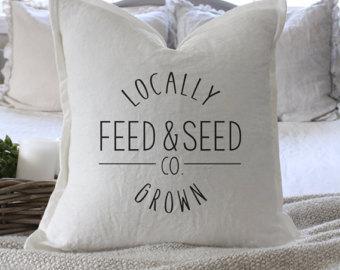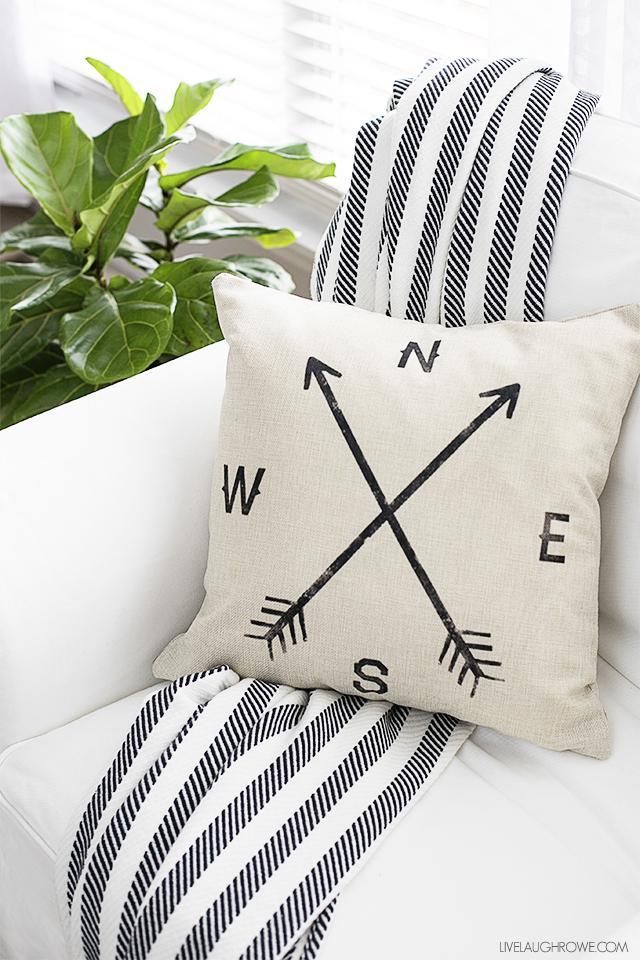The first image is the image on the left, the second image is the image on the right. For the images displayed, is the sentence "One image features a white square pillow with three button closure that is propped against the back of a white chair." factually correct? Answer yes or no. No. The first image is the image on the left, the second image is the image on the right. Analyze the images presented: Is the assertion "The pillow in one of the images has three buttons." valid? Answer yes or no. No. 